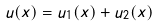<formula> <loc_0><loc_0><loc_500><loc_500>u ( x ) = u _ { 1 } ( x ) + u _ { 2 } ( x )</formula> 